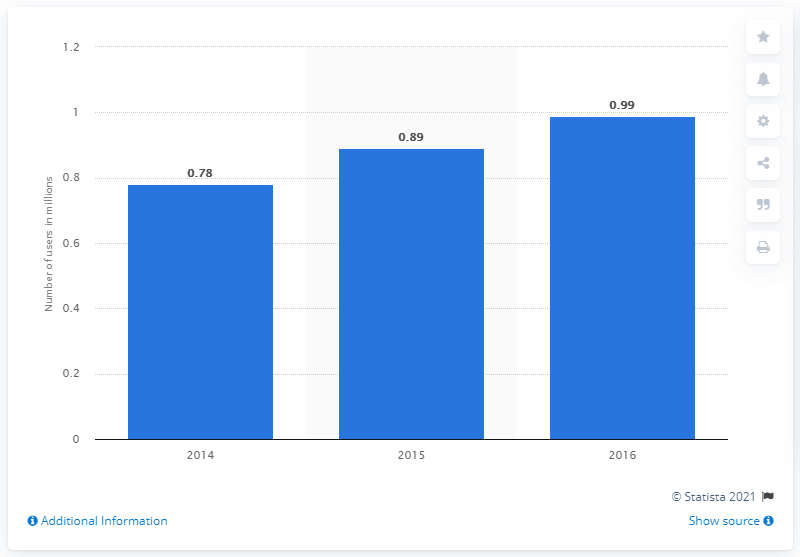Give some essential details in this illustration. As of 2015, the number of active Twitter users in Israel was approximately 0.89 million. 